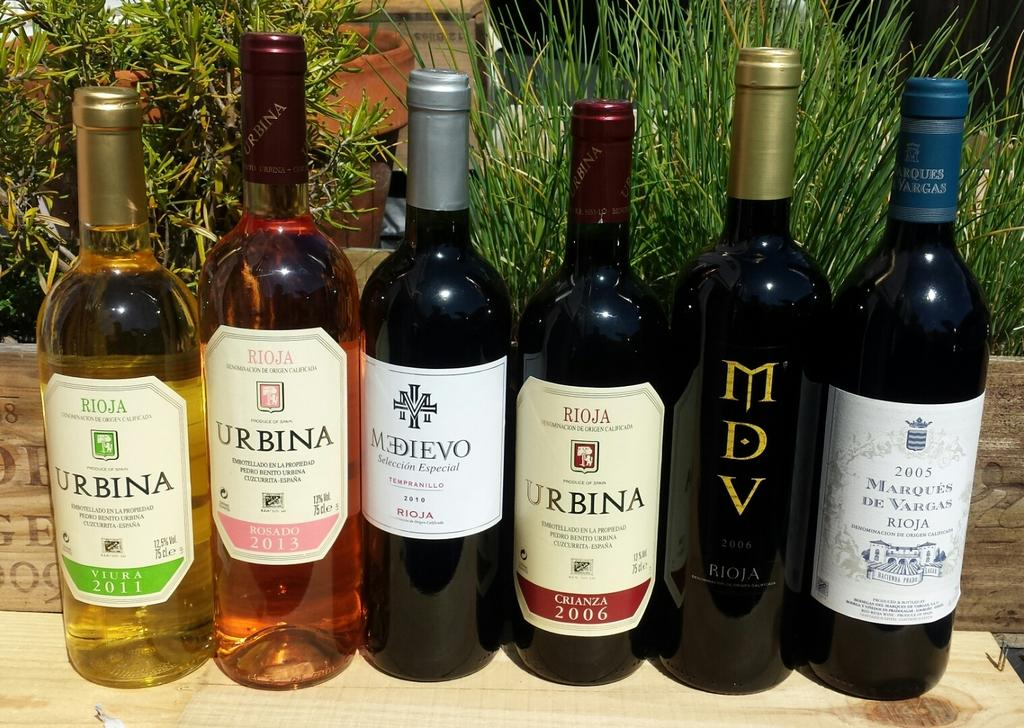<image>
Create a compact narrative representing the image presented. Half on the wines that shown have the name Urbina. 